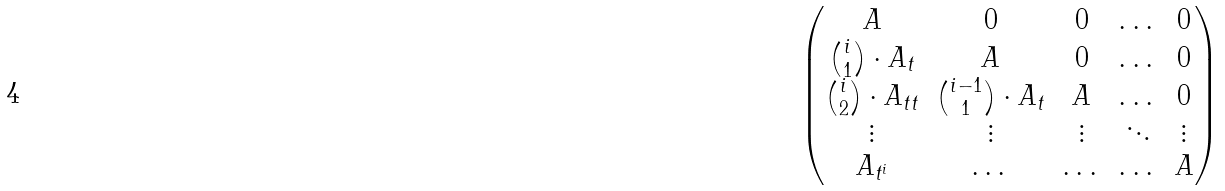Convert formula to latex. <formula><loc_0><loc_0><loc_500><loc_500>\begin{pmatrix} A & 0 & 0 & \dots & 0 \\ \binom { i } { 1 } \cdot A _ { t } & A & 0 & \dots & 0 \\ \binom { i } { 2 } \cdot A _ { t t } & \binom { i - 1 } { 1 } \cdot A _ { t } & A & \dots & 0 \\ \vdots & \vdots & \vdots & \ddots & \vdots \\ A _ { t ^ { i } } & \dots & \dots & \dots & A \end{pmatrix}</formula> 